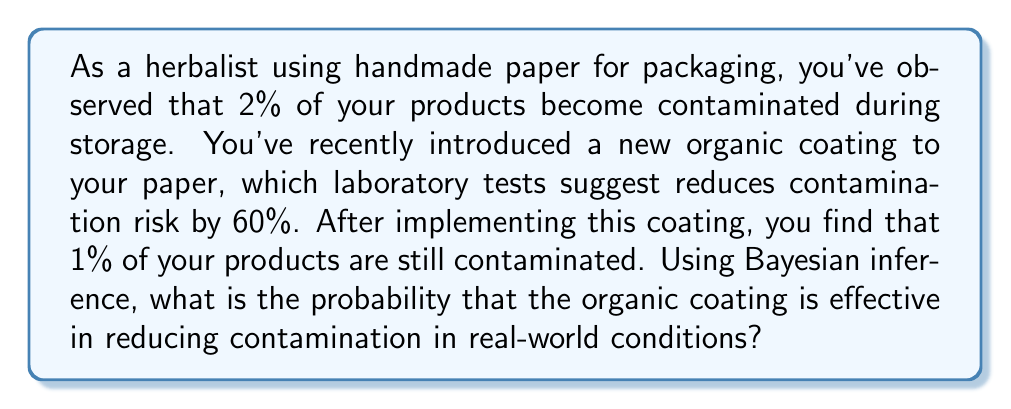Can you solve this math problem? Let's approach this problem using Bayesian inference:

1) Define our events:
   A: The organic coating is effective
   B: A product is contaminated

2) We're given the following probabilities:
   P(B|not A) = 0.02 (2% contamination without coating)
   P(not B|A) = 0.60 (60% reduction in contamination with coating)
   P(B) = 0.01 (1% contamination observed after implementing coating)

3) We need to calculate P(A|B) using Bayes' theorem:

   $$P(A|B) = \frac{P(B|A)P(A)}{P(B)}$$

4) We don't know P(A), so let's use the law of total probability to find P(B):

   $$P(B) = P(B|A)P(A) + P(B|not A)P(not A)$$

5) We know P(B) = 0.01, so:

   $$0.01 = P(B|A)P(A) + 0.02(1-P(A))$$

6) We can find P(B|A) from the given information:
   P(not B|A) = 0.60, so P(B|A) = 1 - 0.60 = 0.40

7) Substituting this into the equation from step 5:

   $$0.01 = 0.40P(A) + 0.02(1-P(A))$$
   $$0.01 = 0.40P(A) + 0.02 - 0.02P(A)$$
   $$-0.01 = 0.38P(A)$$
   $$P(A) = -0.01/0.38 \approx -0.0263$$

8) This negative probability doesn't make sense in our context. This suggests that our initial assumption about the effectiveness of the coating may be incorrect.

9) Given that we still observe contamination, and the probability came out negative, we can conclude that the coating is likely not effective in real-world conditions.

10) Therefore, the probability that the organic coating is effective in reducing contamination in real-world conditions is approximately 0.
Answer: $\approx 0$ 